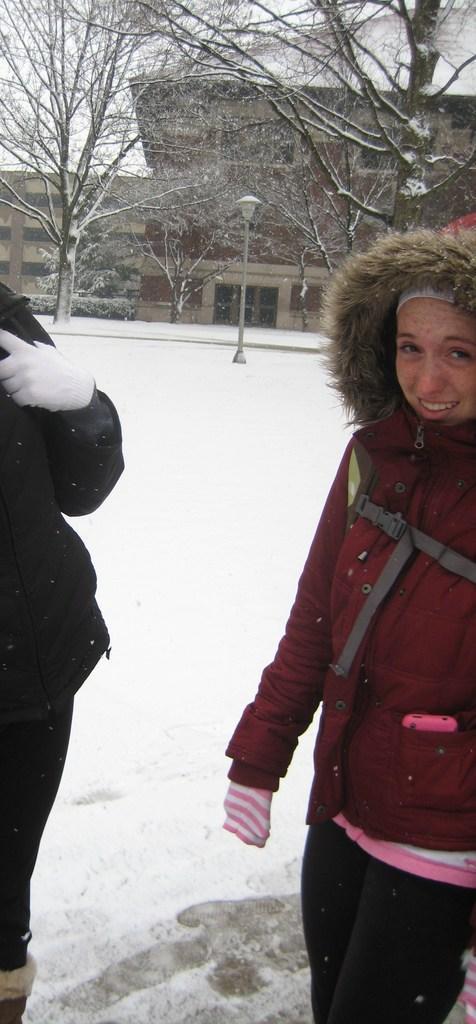Please provide a concise description of this image. In this image we can see two persons standing on the snow. One woman is wearing a red coat and a cap. In the background we can see group of trees ,buildings and pole. 